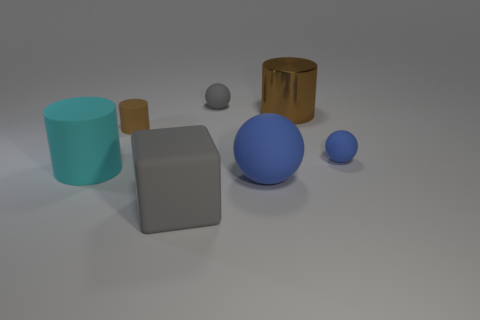Add 1 small spheres. How many objects exist? 8 Subtract all cylinders. How many objects are left? 4 Subtract 2 blue balls. How many objects are left? 5 Subtract all big blue rubber things. Subtract all big cyan rubber cylinders. How many objects are left? 5 Add 3 large spheres. How many large spheres are left? 4 Add 7 tiny cyan things. How many tiny cyan things exist? 7 